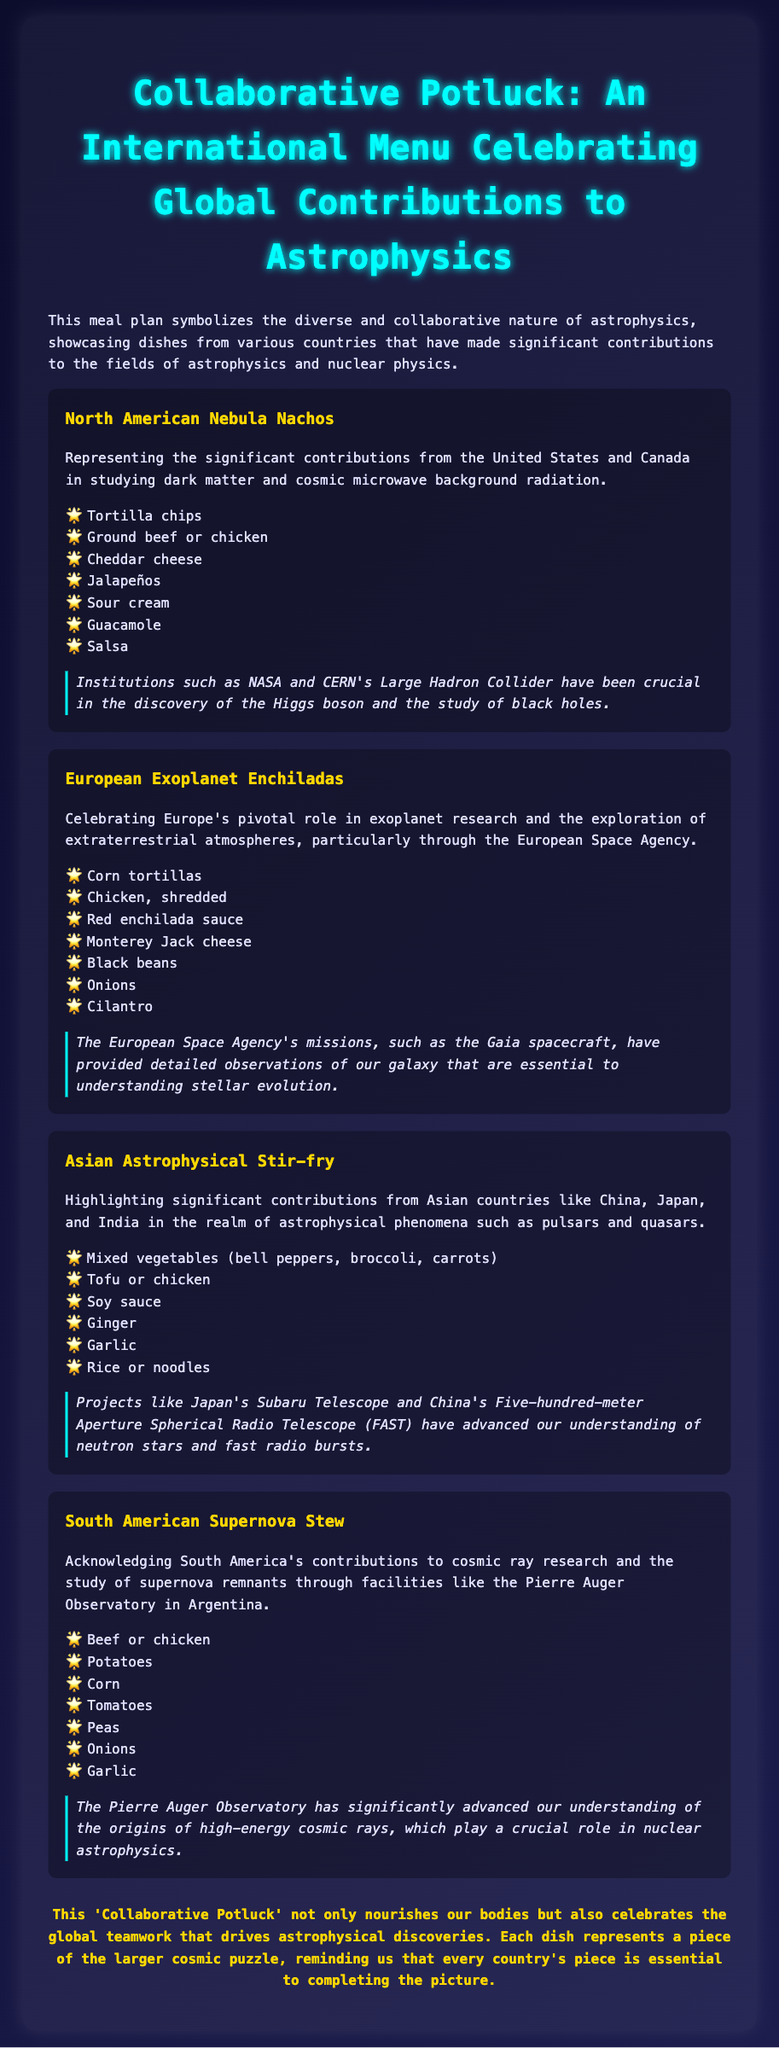What is the title of the meal plan? The title is presented at the top of the document, highlighting the theme of the meal plan.
Answer: Collaborative Potluck: An International Menu Celebrating Global Contributions to Astrophysics How many dishes are included in the meal plan? The document lists four distinct dishes representing different regions.
Answer: Four What is the main ingredient in North American Nebula Nachos? The list of ingredients details the components used in the dish.
Answer: Tortilla chips Which institution is mentioned in relation to South American Supernova Stew? The included scientific contribution provides insights into relevant institutions that have contributed to the research mentioned.
Answer: Pierre Auger Observatory What cuisine does Asian Astrophysical Stir-fry represent? The description indicates that the dish is representative of contributions from multiple Asian countries.
Answer: Asian What type of sauce is used in the European Exoplanet Enchiladas? The ingredient list specifies a particular sauce used in the preparation of this dish.
Answer: Red enchilada sauce Which astronomical phenomenon is associated with South American Supernova Stew? Context in the description highlights the type of research associated with the dish.
Answer: Cosmic rays What scientific framework is highlighted for the European Exoplanet Enchiladas? The scientific contribution provides insights related to key achievements in astrophysics.
Answer: Exoplanet research 